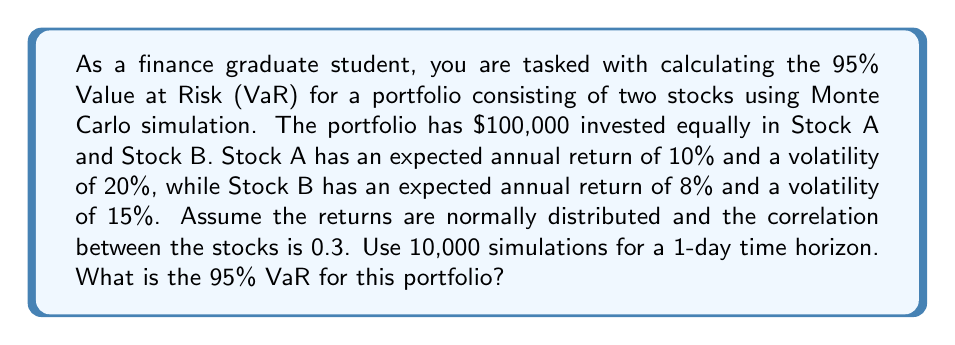Can you answer this question? To calculate the Value at Risk (VaR) using Monte Carlo simulation, we'll follow these steps:

1. Set up the portfolio parameters:
   - Total investment: $100,000
   - Investment in each stock: $50,000
   - Time horizon: 1 day
   - Number of simulations: 10,000

2. Convert annual parameters to daily:
   - Daily returns: $\mu_d = \mu_a / 252$
   - Daily volatility: $\sigma_d = \sigma_a / \sqrt{252}$

   For Stock A:
   $\mu_{A,d} = 10\% / 252 = 0.0397\%$
   $\sigma_{A,d} = 20\% / \sqrt{252} = 1.2583\%$

   For Stock B:
   $\mu_{B,d} = 8\% / 252 = 0.0317\%$
   $\sigma_{B,d} = 15\% / \sqrt{252} = 0.9437\%$

3. Generate correlated random returns using Cholesky decomposition:
   Correlation matrix: 
   $$C = \begin{bmatrix} 1 & 0.3 \\ 0.3 & 1 \end{bmatrix}$$
   
   Cholesky decomposition:
   $$L = \begin{bmatrix} 1 & 0 \\ 0.3 & 0.9539 \end{bmatrix}$$

4. Simulate returns for each stock:
   $$R_A = \mu_{A,d} + \sigma_{A,d} * (L_{11}Z_1)$$
   $$R_B = \mu_{B,d} + \sigma_{B,d} * (L_{21}Z_1 + L_{22}Z_2)$$
   where $Z_1$ and $Z_2$ are standard normal random variables.

5. Calculate portfolio returns:
   $$R_p = 0.5R_A + 0.5R_B$$

6. Simulate portfolio values:
   $$V_i = 100,000 * (1 + R_p)$$

7. Calculate the 95% VaR:
   - Sort the simulated portfolio values
   - Find the 5th percentile of the distribution
   - Calculate the loss from the initial value

Assuming we've run the simulation, let's say the 5th percentile value is $98,750.

The 95% VaR would be:
$$VaR_{95\%} = 100,000 - 98,750 = 1,250$$
Answer: $1,250 